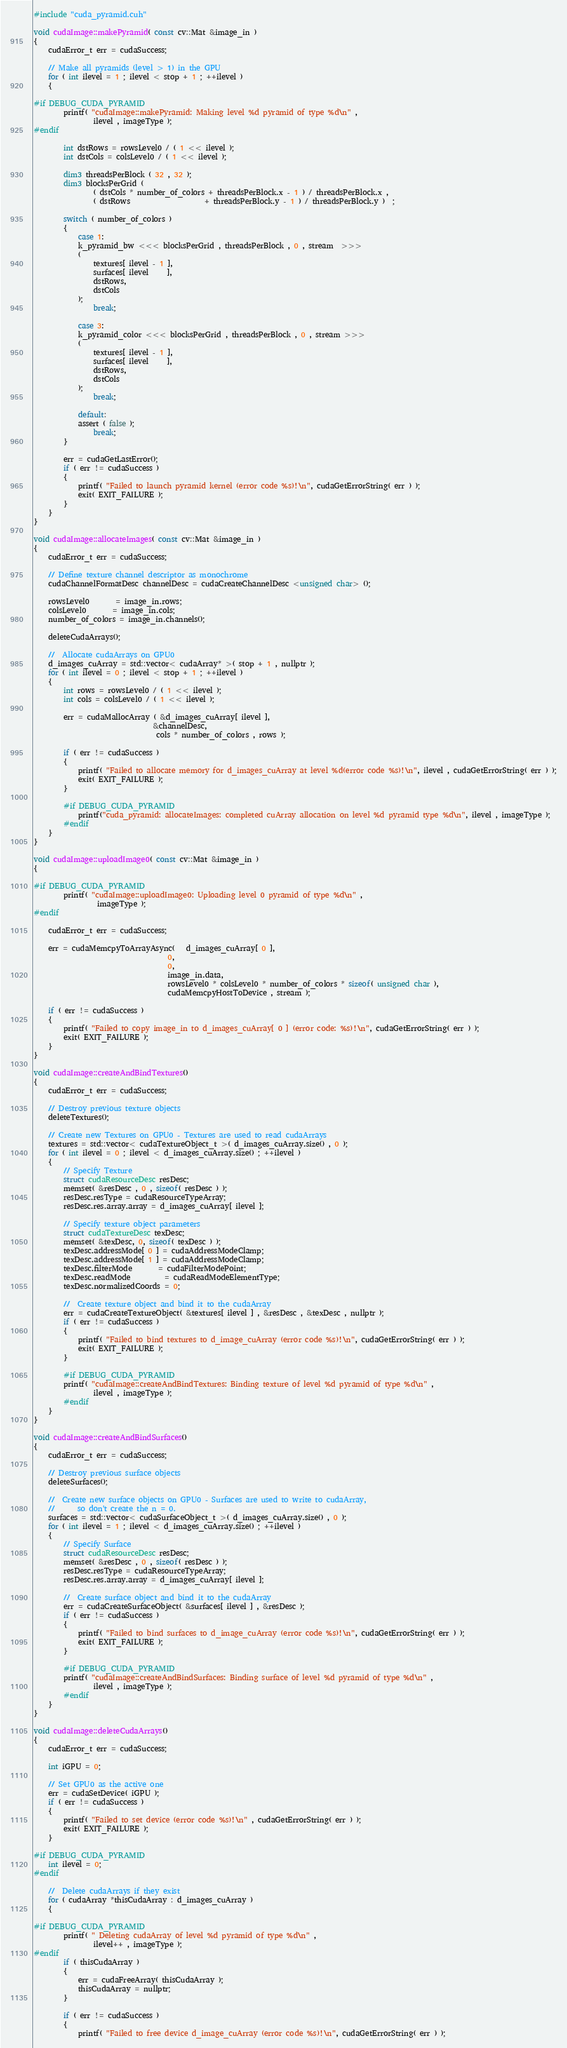Convert code to text. <code><loc_0><loc_0><loc_500><loc_500><_Cuda_>#include "cuda_pyramid.cuh"

void cudaImage::makePyramid( const cv::Mat &image_in )
{
    cudaError_t err = cudaSuccess;

    // Make all pyramids (level > 1) in the GPU
    for ( int ilevel = 1 ; ilevel < stop + 1 ; ++ilevel )
    {

#if DEBUG_CUDA_PYRAMID
        printf( "cudaImage::makePyramid: Making level %d pyramid of type %d\n" ,
                ilevel , imageType );
#endif

        int dstRows = rowsLevel0 / ( 1 << ilevel );
        int dstCols = colsLevel0 / ( 1 << ilevel );

        dim3 threadsPerBlock ( 32 , 32 );
        dim3 blocksPerGrid (
                ( dstCols * number_of_colors + threadsPerBlock.x - 1 ) / threadsPerBlock.x ,
                ( dstRows                    + threadsPerBlock.y - 1 ) / threadsPerBlock.y )  ;

        switch ( number_of_colors )
        {
            case 1:
            k_pyramid_bw <<< blocksPerGrid , threadsPerBlock , 0 , stream  >>>
            (
                textures[ ilevel - 1 ],
                surfaces[ ilevel     ],
                dstRows,
                dstCols
            );
                break;

            case 3:
            k_pyramid_color <<< blocksPerGrid , threadsPerBlock , 0 , stream >>>
            (
                textures[ ilevel - 1 ],
                surfaces[ ilevel     ],
                dstRows,
                dstCols
            );
                break;

            default:
            assert ( false );
                break;
        }

        err = cudaGetLastError();
        if ( err != cudaSuccess )
        {
            printf( "Failed to launch pyramid kernel (error code %s)!\n", cudaGetErrorString( err ) );
            exit( EXIT_FAILURE );
        }
    }
}

void cudaImage::allocateImages( const cv::Mat &image_in )
{
    cudaError_t err = cudaSuccess;

    // Define texture channel descriptor as monochrome
    cudaChannelFormatDesc channelDesc = cudaCreateChannelDesc <unsigned char> ();

    rowsLevel0       = image_in.rows;
    colsLevel0       = image_in.cols;
    number_of_colors = image_in.channels();

    deleteCudaArrays();

    //  Allocate cudaArrays on GPU0
    d_images_cuArray = std::vector< cudaArray* >( stop + 1 , nullptr );
    for ( int ilevel = 0 ; ilevel < stop + 1 ; ++ilevel )
    {
        int rows = rowsLevel0 / ( 1 << ilevel );
        int cols = colsLevel0 / ( 1 << ilevel );

        err = cudaMallocArray ( &d_images_cuArray[ ilevel ],
                                &channelDesc,
                                 cols * number_of_colors , rows );

        if ( err != cudaSuccess )
        {
            printf( "Failed to allocate memory for d_images_cuArray at level %d(error code %s)!\n", ilevel , cudaGetErrorString( err ) );
            exit( EXIT_FAILURE );
        }

        #if DEBUG_CUDA_PYRAMID
            printf("cuda_pyramid: allocateImages: completed cuArray allocation on level %d pyramid type %d\n", ilevel , imageType );
        #endif
    }
}

void cudaImage::uploadImage0( const cv::Mat &image_in )
{

#if DEBUG_CUDA_PYRAMID
        printf( "cudaImage::uploadImage0: Uploading level 0 pyramid of type %d\n" ,
                 imageType );
#endif

    cudaError_t err = cudaSuccess;

    err = cudaMemcpyToArrayAsync(   d_images_cuArray[ 0 ],
                                    0,
                                    0,
                                    image_in.data,
                                    rowsLevel0 * colsLevel0 * number_of_colors * sizeof( unsigned char ),
                                    cudaMemcpyHostToDevice , stream );

    if ( err != cudaSuccess )
    {
        printf( "Failed to copy image_in to d_images_cuArray[ 0 ] (error code: %s)!\n", cudaGetErrorString( err ) );
        exit( EXIT_FAILURE );
    }
}

void cudaImage::createAndBindTextures()
{
    cudaError_t err = cudaSuccess;

    // Destroy previous texture objects
    deleteTextures();

    // Create new Textures on GPU0 - Textures are used to read cudaArrays
    textures = std::vector< cudaTextureObject_t >( d_images_cuArray.size() , 0 );
    for ( int ilevel = 0 ; ilevel < d_images_cuArray.size() ; ++ilevel )
    {
        // Specify Texture
        struct cudaResourceDesc resDesc;
        memset( &resDesc , 0 , sizeof( resDesc ) );
        resDesc.resType = cudaResourceTypeArray;
        resDesc.res.array.array = d_images_cuArray[ ilevel ];

        // Specify texture object parameters
        struct cudaTextureDesc texDesc;
        memset( &texDesc, 0, sizeof( texDesc ) );
        texDesc.addressMode[ 0 ] = cudaAddressModeClamp;
        texDesc.addressMode[ 1 ] = cudaAddressModeClamp;
        texDesc.filterMode       = cudaFilterModePoint;
        texDesc.readMode         = cudaReadModeElementType;
        texDesc.normalizedCoords = 0;

        //  Create texture object and bind it to the cudaArray
        err = cudaCreateTextureObject( &textures[ ilevel ] , &resDesc , &texDesc , nullptr );
        if ( err != cudaSuccess )
        {
            printf( "Failed to bind textures to d_image_cuArray (error code %s)!\n", cudaGetErrorString( err ) );
            exit( EXIT_FAILURE );
        }

        #if DEBUG_CUDA_PYRAMID
        printf( "cudaImage::createAndBindTextures: Binding texture of level %d pyramid of type %d\n" ,
                ilevel , imageType );
        #endif
    }
}

void cudaImage::createAndBindSurfaces()
{
    cudaError_t err = cudaSuccess;

    // Destroy previous surface objects
    deleteSurfaces();

    //  Create new surface objects on GPU0 - Surfaces are used to write to cudaArray,
    //      so don't create the n = 0.
    surfaces = std::vector< cudaSurfaceObject_t >( d_images_cuArray.size() , 0 );
    for ( int ilevel = 1 ; ilevel < d_images_cuArray.size() ; ++ilevel )
    {
        // Specify Surface
        struct cudaResourceDesc resDesc;
        memset( &resDesc , 0 , sizeof( resDesc ) );
        resDesc.resType = cudaResourceTypeArray;
        resDesc.res.array.array = d_images_cuArray[ ilevel ];

        //  Create surface object and bind it to the cudaArray
        err = cudaCreateSurfaceObject( &surfaces[ ilevel ] , &resDesc );
        if ( err != cudaSuccess )
        {
            printf( "Failed to bind surfaces to d_image_cuArray (error code %s)!\n", cudaGetErrorString( err ) );
            exit( EXIT_FAILURE );
        }

        #if DEBUG_CUDA_PYRAMID
        printf( "cudaImage::createAndBindSurfaces: Binding surface of level %d pyramid of type %d\n" ,
                ilevel , imageType );
        #endif
    }
}

void cudaImage::deleteCudaArrays()
{
    cudaError_t err = cudaSuccess;

    int iGPU = 0;

    // Set GPU0 as the active one
    err = cudaSetDevice( iGPU );
    if ( err != cudaSuccess )
    {
        printf( "Failed to set device (error code %s)!\n" , cudaGetErrorString( err ) );
        exit( EXIT_FAILURE );
    }

#if DEBUG_CUDA_PYRAMID
    int ilevel = 0;
#endif

    //  Delete cudaArrays if they exist
    for ( cudaArray *thisCudaArray : d_images_cuArray )
    {

#if DEBUG_CUDA_PYRAMID
        printf( " Deleting cudaArray of level %d pyramid of type %d\n" ,
                ilevel++ , imageType );
#endif
        if ( thisCudaArray )
        {
            err = cudaFreeArray( thisCudaArray );
            thisCudaArray = nullptr;
        }

        if ( err != cudaSuccess )
        {
            printf( "Failed to free device d_image_cuArray (error code %s)!\n", cudaGetErrorString( err ) );</code> 